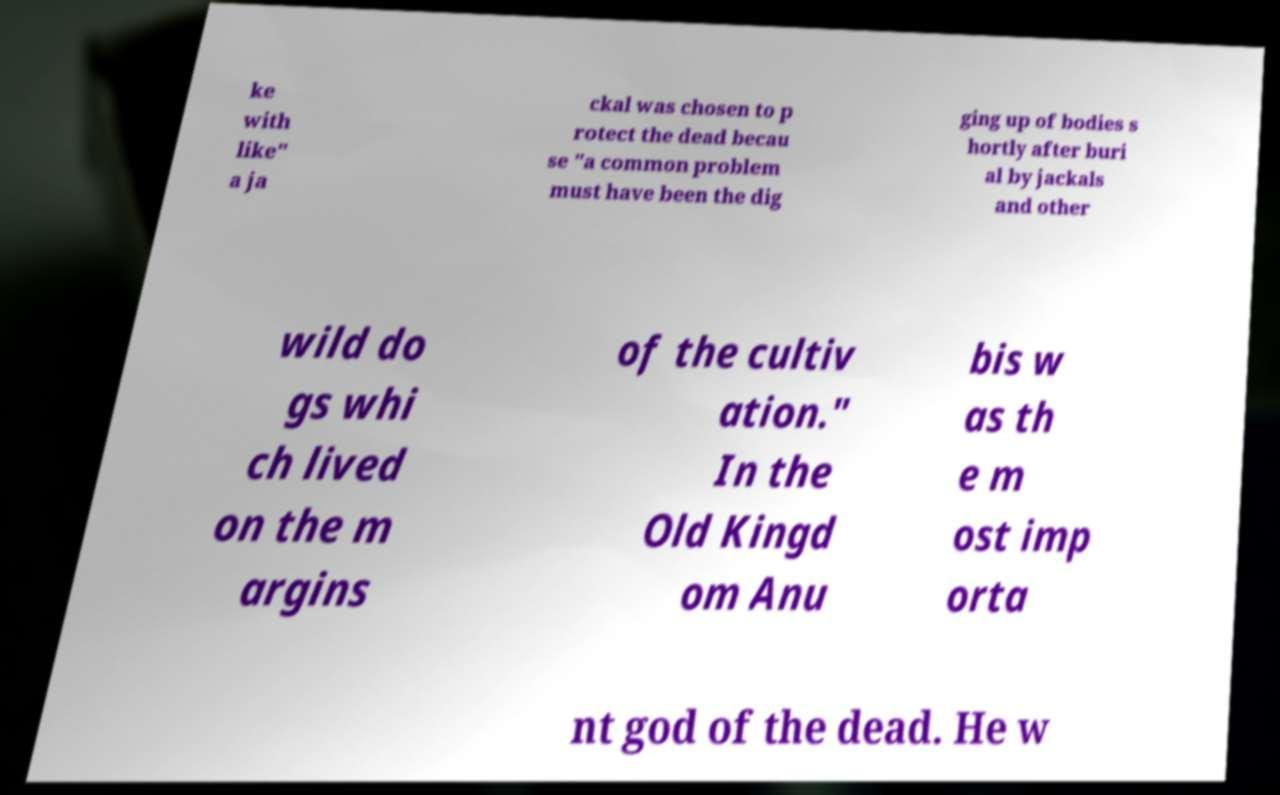There's text embedded in this image that I need extracted. Can you transcribe it verbatim? ke with like" a ja ckal was chosen to p rotect the dead becau se "a common problem must have been the dig ging up of bodies s hortly after buri al by jackals and other wild do gs whi ch lived on the m argins of the cultiv ation." In the Old Kingd om Anu bis w as th e m ost imp orta nt god of the dead. He w 